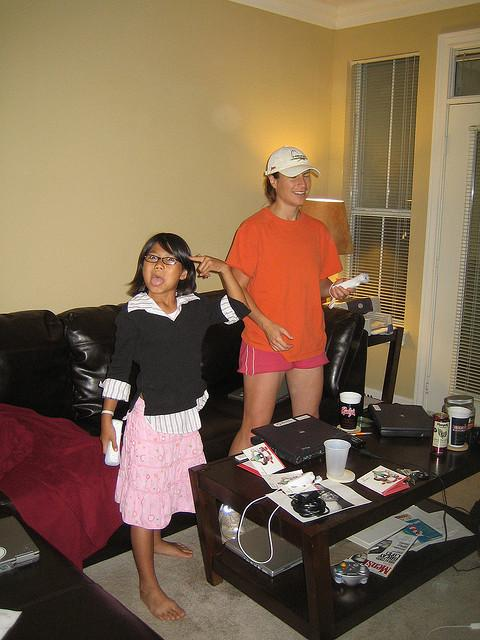What is the girl pointing to?

Choices:
A) elbow
B) head
C) knee
D) foot head 